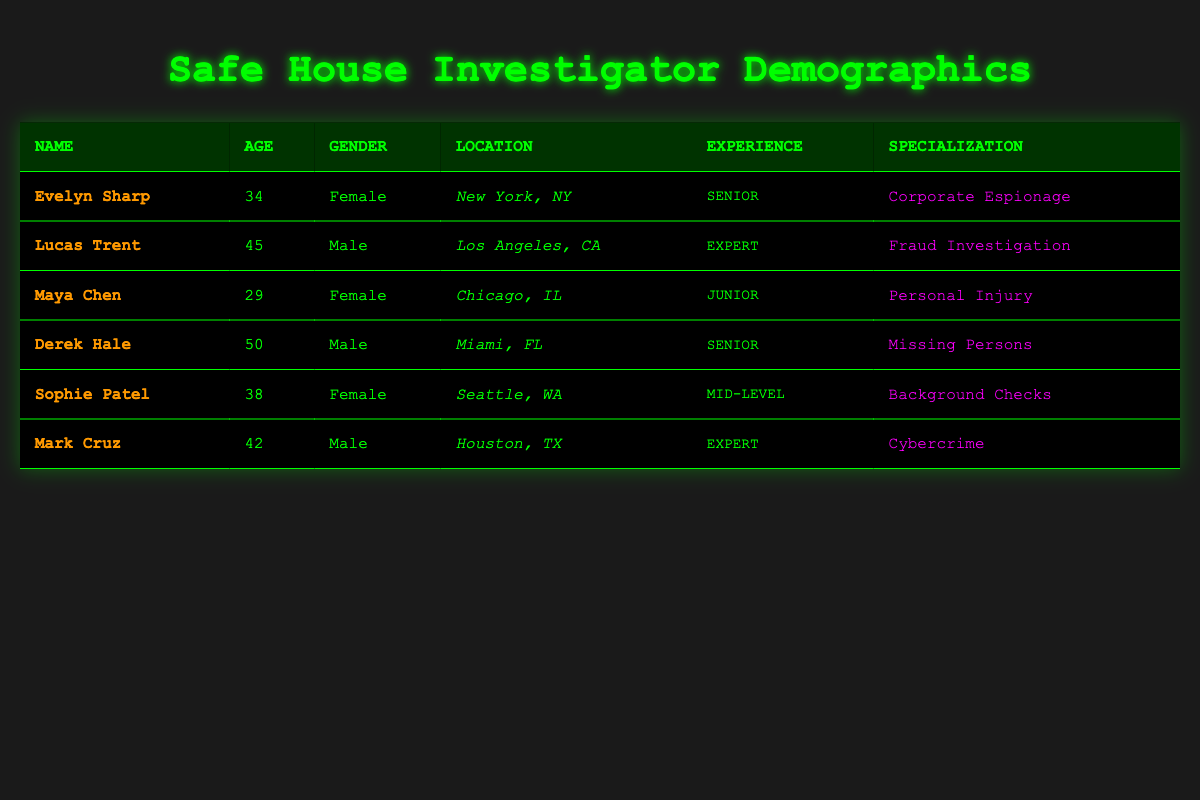What is the gender distribution of the investigators? There are three females (Evelyn Sharp, Maya Chen, and Sophie Patel) and three males (Lucas Trent, Derek Hale, and Mark Cruz) in the table. Therefore, the gender distribution is equal, with 50% male and 50% female investigators.
Answer: Equal distribution Who is the youngest investigator listed in the table? The youngest investigator is Maya Chen, who is 29 years old. I found this by comparing the ages of all investigators and identifying the minimum age.
Answer: Maya Chen How many investigators have an experience level of "Expert"? There are two investigators with an experience level of "Expert": Lucas Trent and Mark Cruz. I determined this by counting the rows where the experience level matches "Expert."
Answer: Two What is the average age of the investigators? The ages are 34, 45, 29, 50, 38, and 42. Summing these gives (34 + 45 + 29 + 50 + 38 + 42) = 238. There are six investigators, so the average age is 238/6 = 39.67.
Answer: 39.67 Is there an investigator specializing in "Cybercrime"? Yes, there is one investigator specializing in "Cybercrime," who is Mark Cruz. I checked the case type specialization column for any investigators with that specialization and found Mark Cruz.
Answer: Yes How many investigators are located in the state of Florida? There is one investigator from Florida, which is Derek Hale. I confirmed this by checking the location column for occurrences of "FL."
Answer: One What is the difference in age between the oldest and youngest investigators? The oldest investigator is Derek Hale at 50 years old, and the youngest is Maya Chen at 29 years old. The age difference is calculated as 50 - 29 = 21.
Answer: 21 How many investigators specialize in "Missing Persons" and "Background Checks"? There are two specializations mentioned: one investigator, Derek Hale, specializes in "Missing Persons," and another, Sophie Patel, specializes in "Background Checks." Therefore, there are a total of two.
Answer: Two What proportion of investigators are considered "Senior" level? There are two investigators (Evelyn Sharp and Derek Hale) classified as "Senior." With six total investigators, the proportion is calculated as 2/6 = 1/3 or approximately 33.33%.
Answer: One-third 